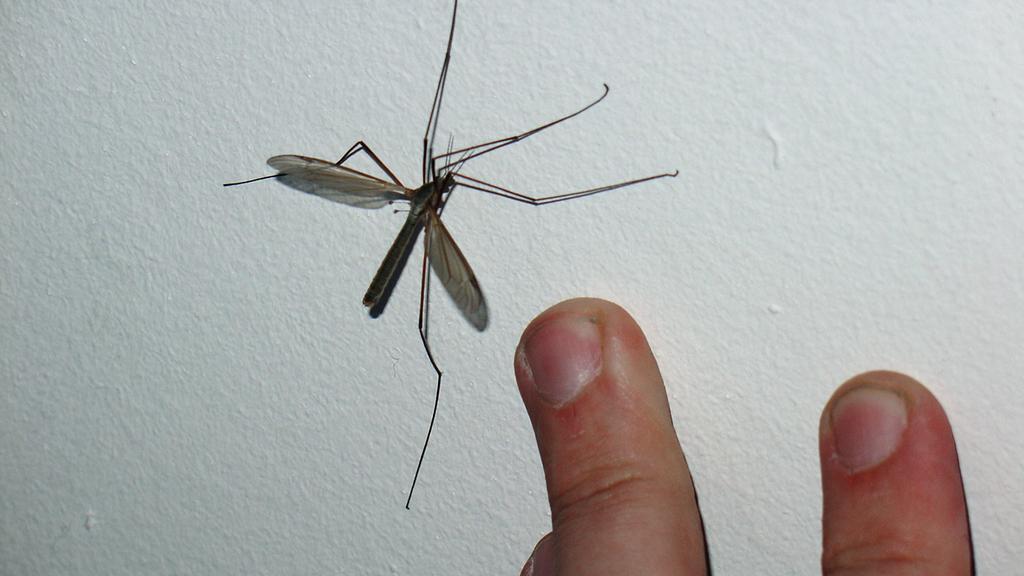Please provide a concise description of this image. In this image in the center there is an insect and at the bottom of the image there are fingers of the person. 